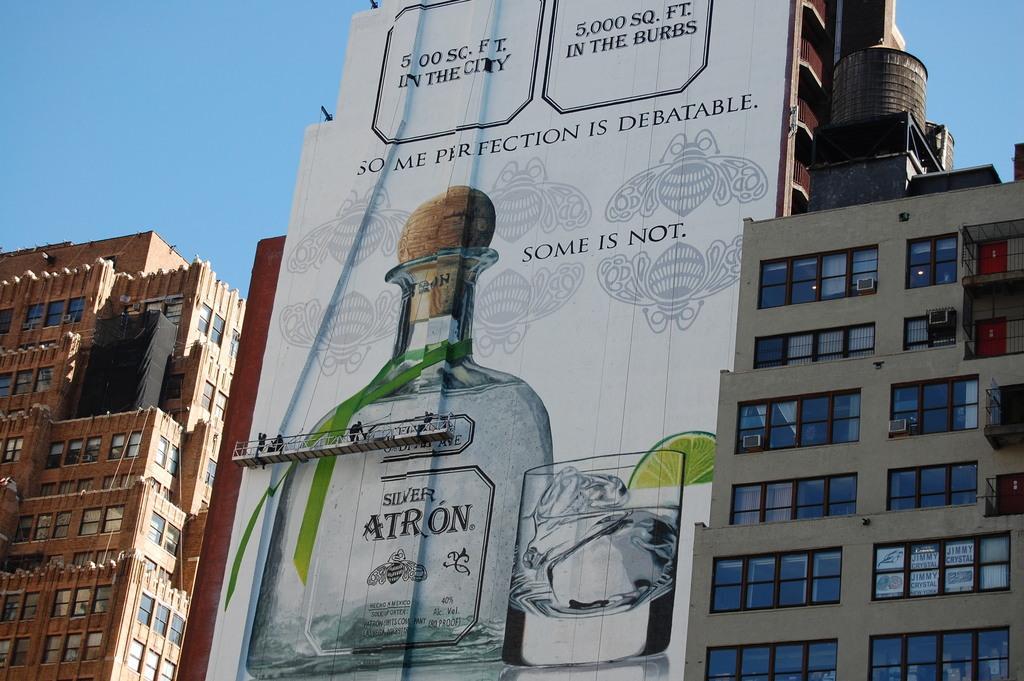How would you summarize this image in a sentence or two? In this image I see number of buildings and I see a banner over here on which there are numbers and words written and I see a small bottle and a glass and I see few people over here on this thing. In the background I see the blue sky. 